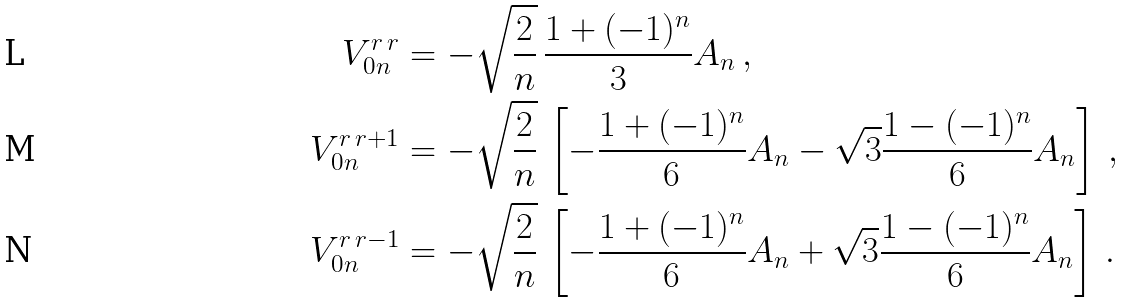<formula> <loc_0><loc_0><loc_500><loc_500>V ^ { r \, r } _ { 0 n } & = - \sqrt { \frac { 2 } { n } } \, \frac { 1 + ( - 1 ) ^ { n } } { 3 } A _ { n } \, , \\ V ^ { r \, r + 1 } _ { 0 n } & = - \sqrt { \frac { 2 } { n } } \, \left [ - \frac { 1 + ( - 1 ) ^ { n } } { 6 } A _ { n } - \sqrt { 3 } \frac { 1 - ( - 1 ) ^ { n } } { 6 } A _ { n } \right ] \, , \\ V ^ { r \, r - 1 } _ { 0 n } & = - \sqrt { \frac { 2 } { n } } \, \left [ - \frac { 1 + ( - 1 ) ^ { n } } { 6 } A _ { n } + \sqrt { 3 } \frac { 1 - ( - 1 ) ^ { n } } { 6 } A _ { n } \right ] \, .</formula> 